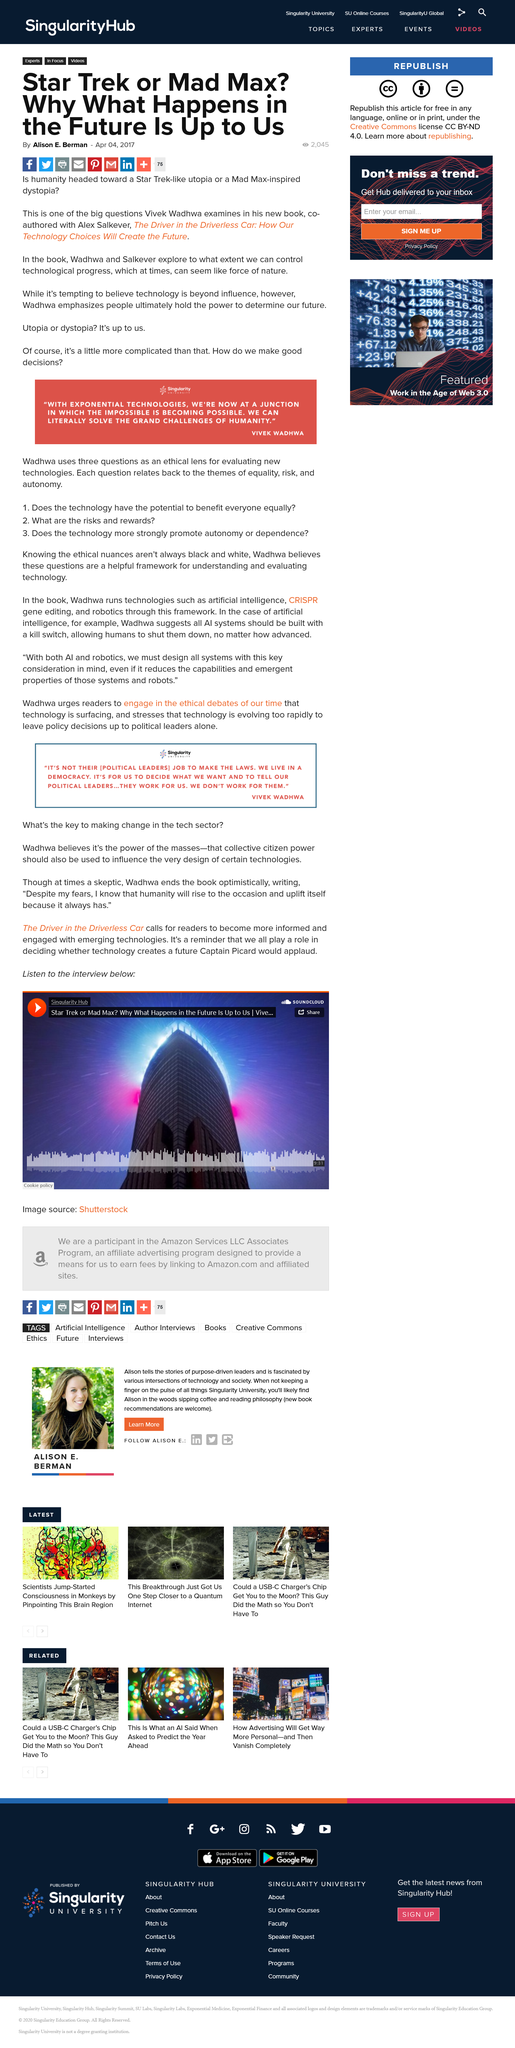Draw attention to some important aspects in this diagram. Utopia, as a concept, is often characterized as a future society free of conflict and harm, similar to the Star Wars universe, rather than the dystopian Mad Max universe. Wadhwa believes that the power of the masses can be used to influence the design of certain technologies. The article mentions Captain Picard. The title of the movie is "Star Trek," and it is either a reference to the popular science fiction franchise or an unknown entity. The Mad Max movie, on the other hand, is a post-apocalyptic action film that has gained significant popularity. In his book, Wadhwa emphasizes that people have the power to determine our future and shape it according to their will. 